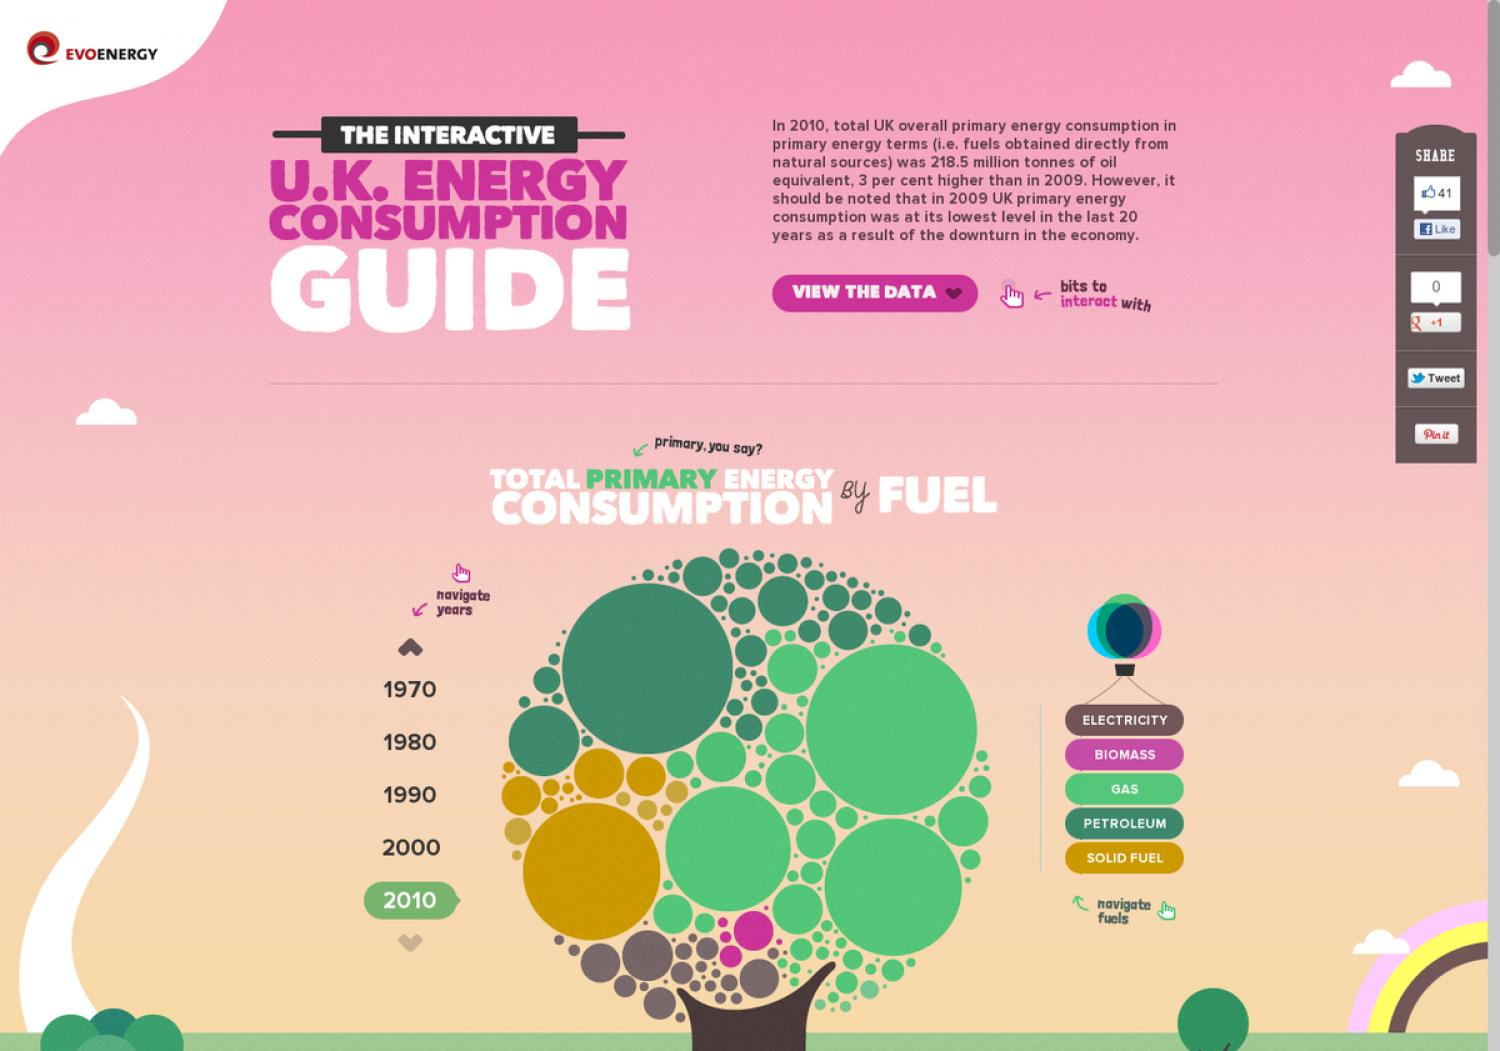Outline some significant characteristics in this image. Biomass is represented by the color pink. It is a fuel that is derived from organic matter, such as plant materials or waste products. Biomass can be burned to produce heat or electricity, and it is often used as a renewable energy source. It is important to note that biomass can be burned in a clean and efficient manner, making it a sustainable alternative to other forms of fossil fuels. The word "guide" is written in white. The text "view the data" is written in white color. The third fuel on the list is gas. The year that is given fourth in the list is 2000. 